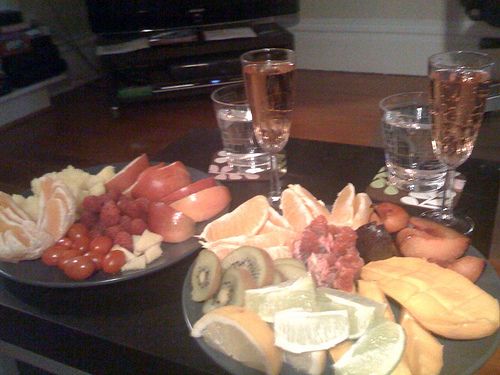Is this spread appropriate for a particular type of event or gathering? The fruit platter and accompanying beverages could suggest this spread is suitable for a casual social gathering, perhaps a brunch or a healthy snack option during a small get-together. 